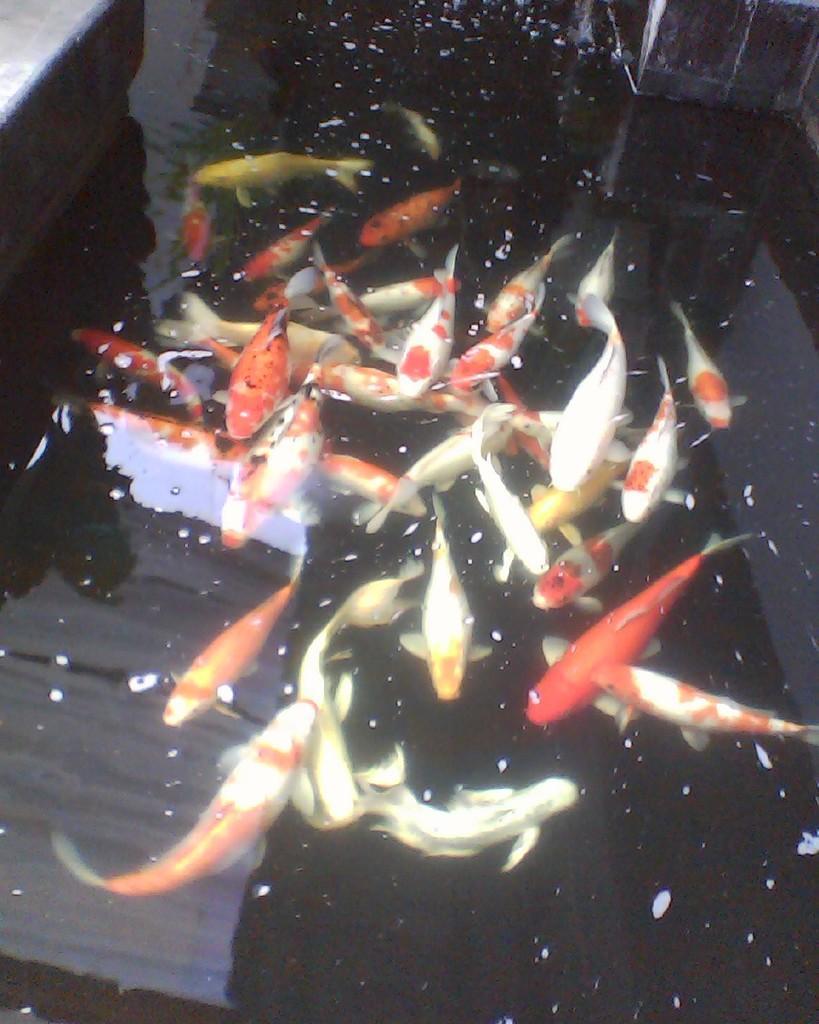Can you describe this image briefly? In this image we can see some fishes which are there in water body. 